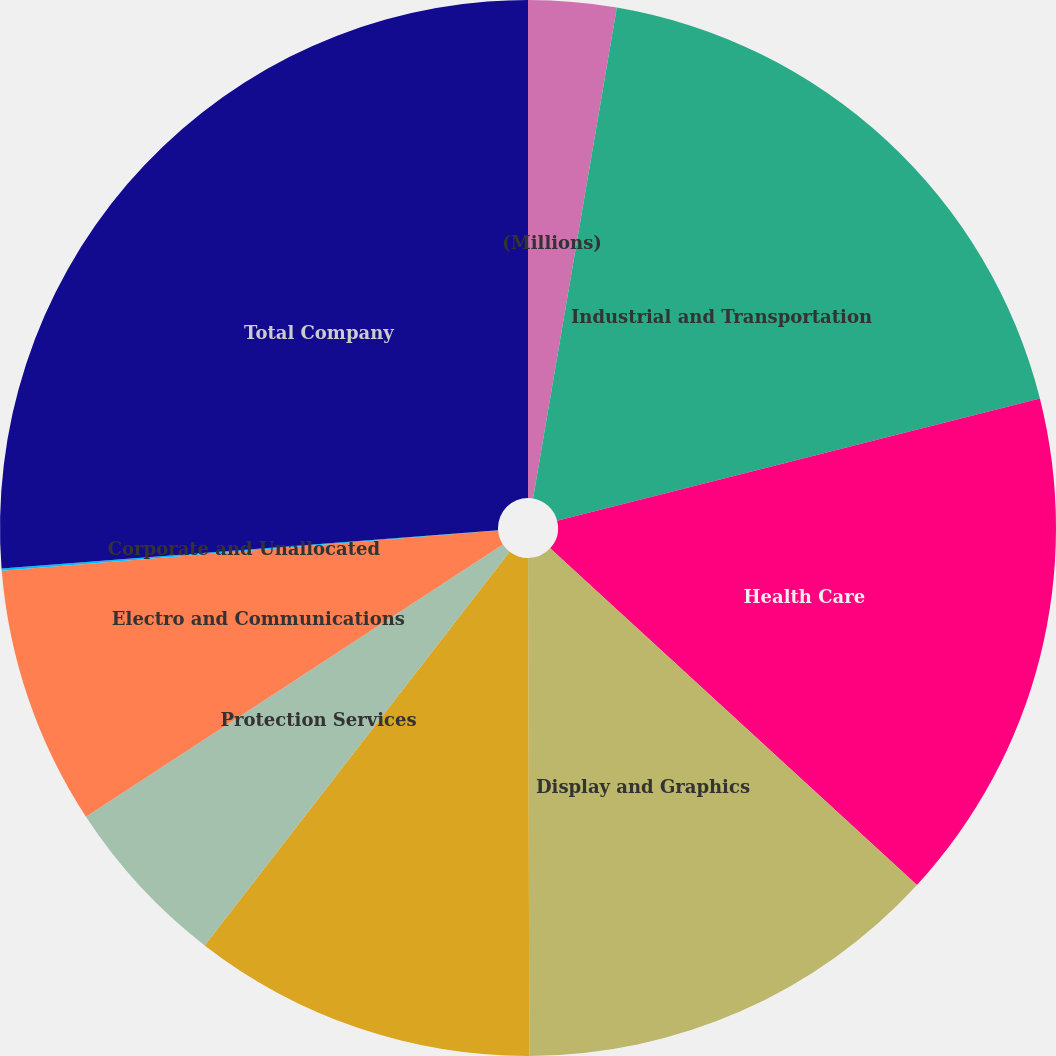<chart> <loc_0><loc_0><loc_500><loc_500><pie_chart><fcel>(Millions)<fcel>Industrial and Transportation<fcel>Health Care<fcel>Display and Graphics<fcel>Consumer and Office<fcel>Protection Services<fcel>Electro and Communications<fcel>Corporate and Unallocated<fcel>Total Company<nl><fcel>2.69%<fcel>18.37%<fcel>15.76%<fcel>13.14%<fcel>10.53%<fcel>5.3%<fcel>7.92%<fcel>0.07%<fcel>26.22%<nl></chart> 